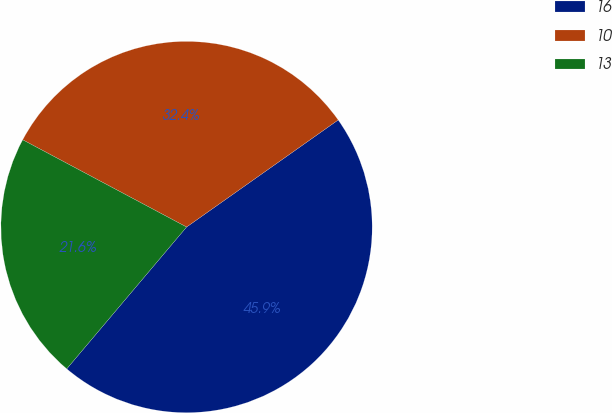Convert chart to OTSL. <chart><loc_0><loc_0><loc_500><loc_500><pie_chart><fcel>16<fcel>10<fcel>13<nl><fcel>45.95%<fcel>32.43%<fcel>21.62%<nl></chart> 